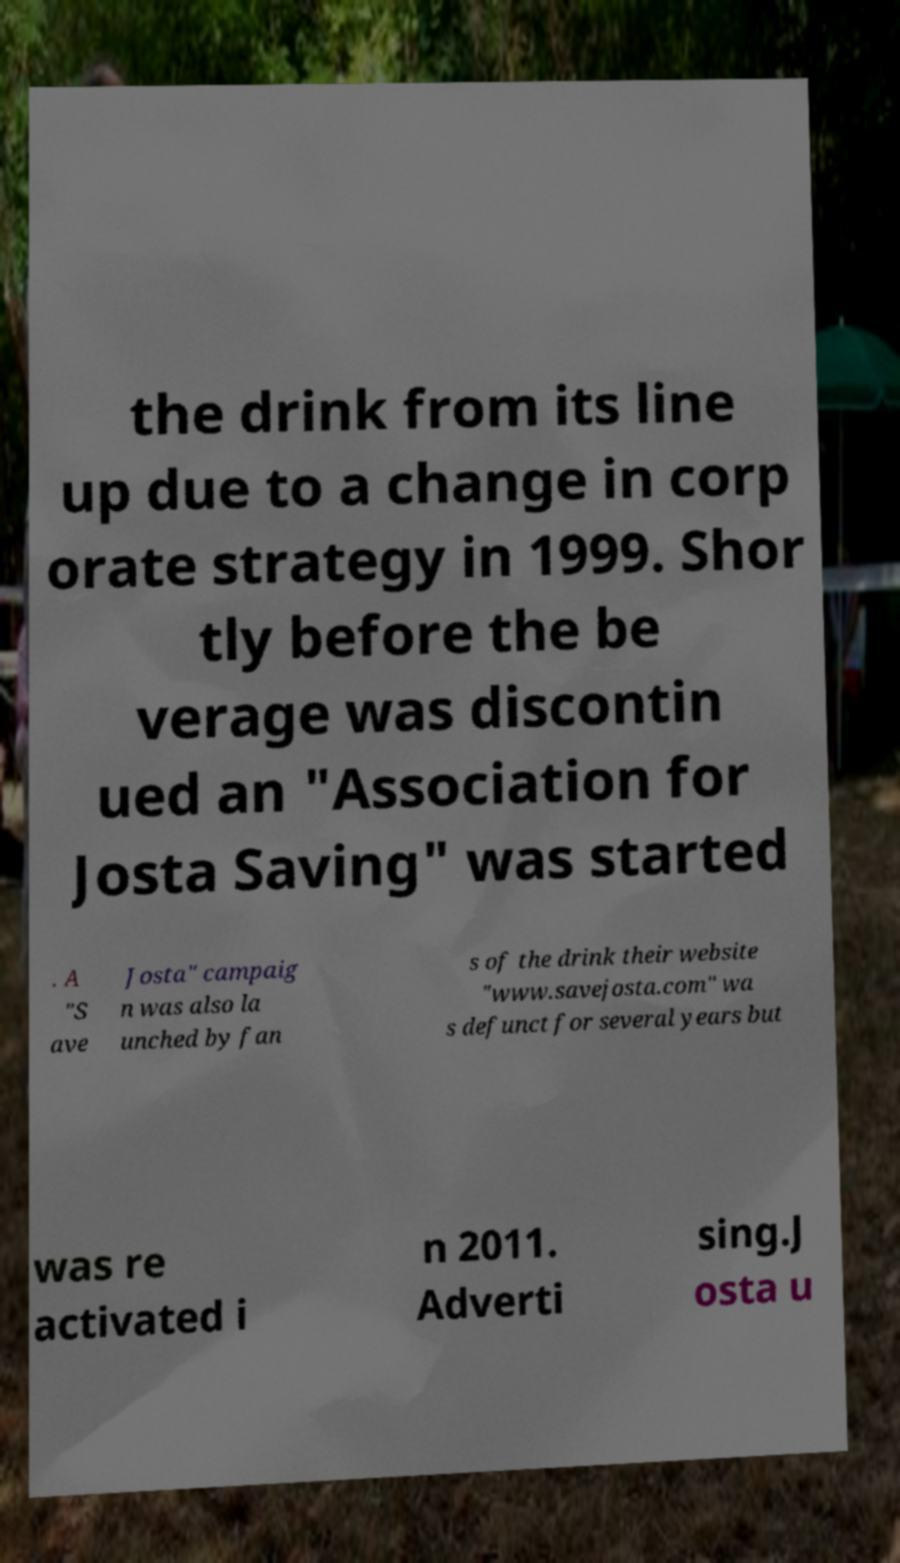I need the written content from this picture converted into text. Can you do that? the drink from its line up due to a change in corp orate strategy in 1999. Shor tly before the be verage was discontin ued an "Association for Josta Saving" was started . A "S ave Josta" campaig n was also la unched by fan s of the drink their website "www.savejosta.com" wa s defunct for several years but was re activated i n 2011. Adverti sing.J osta u 